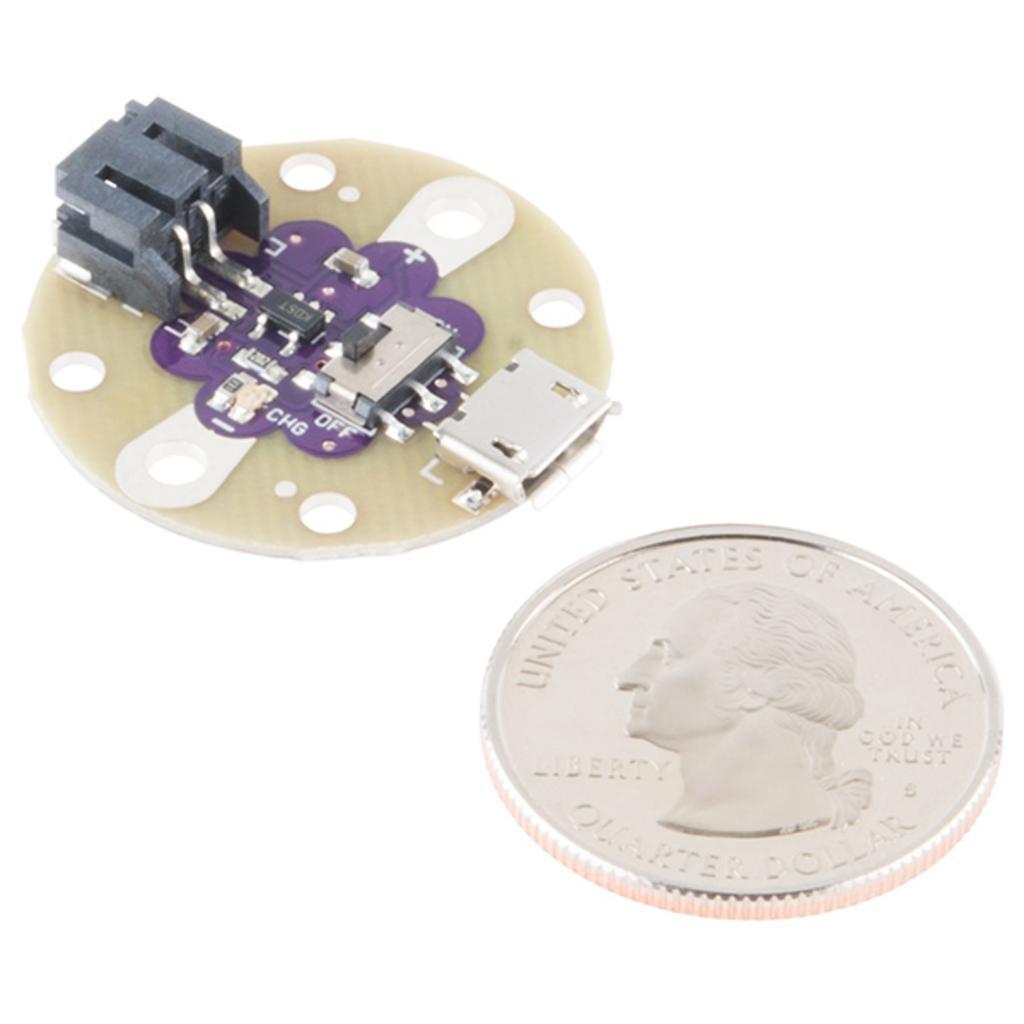Describe this image in one or two sentences. In the picture we can see an electronic device with a chip and beside it, we can see a coin with a symbol of a person side view of a head and written on it as the United States of America. 